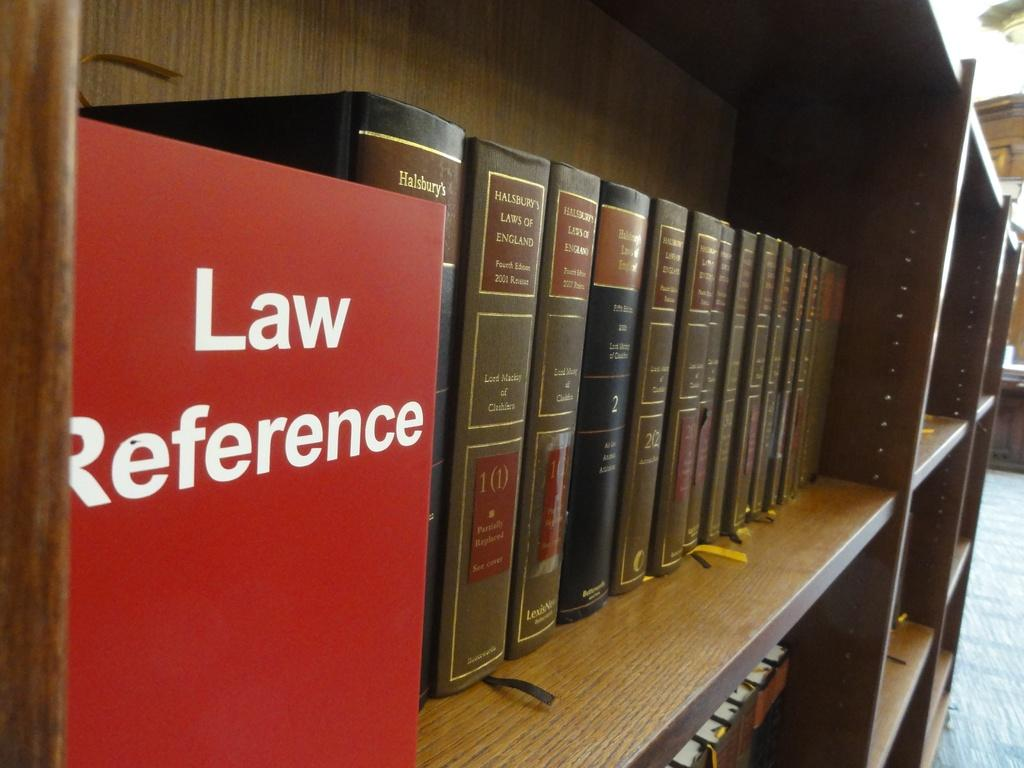<image>
Provide a brief description of the given image. Several books sit on a shelf in the library in the Law Reference section. 